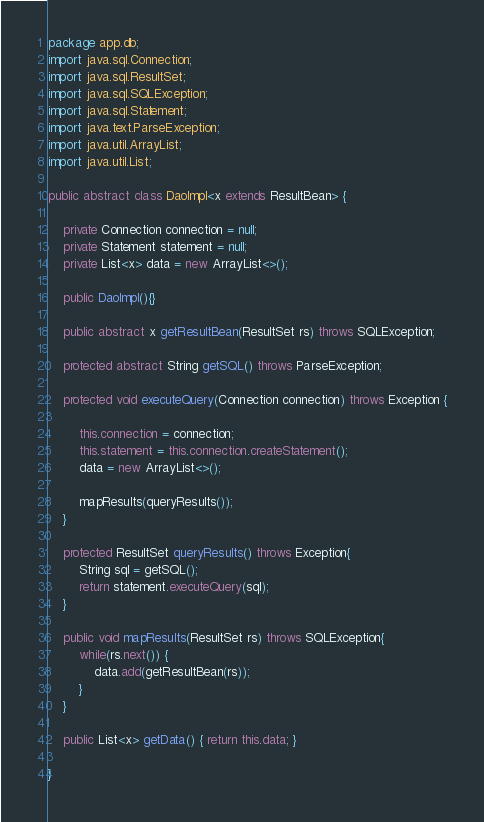Convert code to text. <code><loc_0><loc_0><loc_500><loc_500><_Java_>package app.db;
import java.sql.Connection;
import java.sql.ResultSet;
import java.sql.SQLException;
import java.sql.Statement;
import java.text.ParseException;
import java.util.ArrayList;
import java.util.List;

public abstract class DaoImpl<x extends ResultBean> {

    private Connection connection = null;
    private Statement statement = null;
    private List<x> data = new ArrayList<>();

    public DaoImpl(){}

    public abstract x getResultBean(ResultSet rs) throws SQLException;

    protected abstract String getSQL() throws ParseException;

    protected void executeQuery(Connection connection) throws Exception {

        this.connection = connection;
        this.statement = this.connection.createStatement();
        data = new ArrayList<>();

        mapResults(queryResults());
    }

    protected ResultSet queryResults() throws Exception{
        String sql = getSQL();
        return statement.executeQuery(sql);
    }

    public void mapResults(ResultSet rs) throws SQLException{
        while(rs.next()) {
            data.add(getResultBean(rs));
        }
    }

    public List<x> getData() { return this.data; }

}</code> 